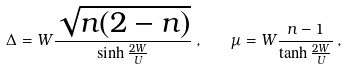Convert formula to latex. <formula><loc_0><loc_0><loc_500><loc_500>\Delta = W \frac { \sqrt { n ( 2 - n ) } } { \sinh \frac { 2 W } { U } } \, , \quad \mu = W \frac { n - 1 } { \tanh \frac { 2 W } { U } } \, ,</formula> 